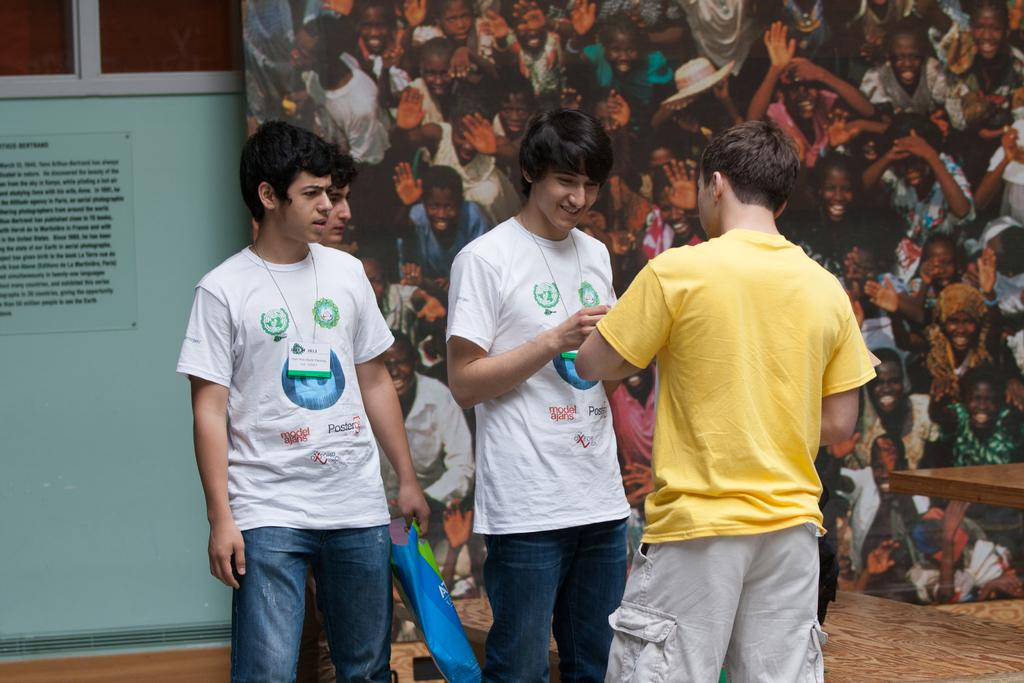How many people are present in the image? There are three people standing in the center of the image. What can be seen in the background of the image? There is a board in the background of the image. What is located on the right side of the image? There is a table on the right side of the image. What is on the left side of the image? There is a wall on the left side of the image. What type of beef is being served on the chair in the image? There is no beef or chair present in the image. 